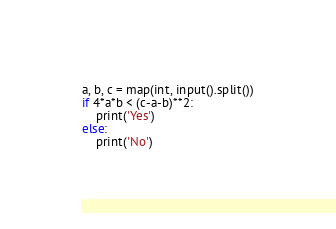Convert code to text. <code><loc_0><loc_0><loc_500><loc_500><_Python_>a, b, c = map(int, input().split())
if 4*a*b < (c-a-b)**2:
    print('Yes')
else:
    print('No')</code> 